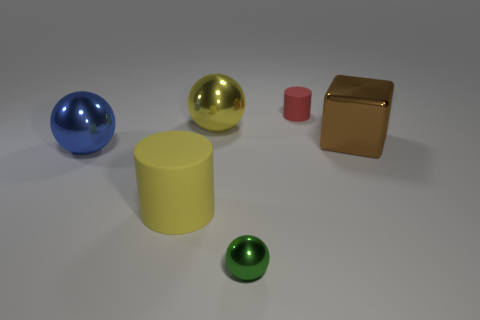There is another big object that is the same shape as the red matte thing; what color is it?
Offer a very short reply. Yellow. Are there any other things that have the same shape as the red object?
Your answer should be very brief. Yes. Do the small red rubber thing and the large object on the right side of the small green object have the same shape?
Ensure brevity in your answer.  No. What is the material of the yellow cylinder?
Ensure brevity in your answer.  Rubber. What size is the other matte object that is the same shape as the large matte thing?
Make the answer very short. Small. What number of other things are there of the same material as the blue sphere
Your answer should be compact. 3. Does the large brown block have the same material as the tiny sphere that is to the right of the big blue ball?
Ensure brevity in your answer.  Yes. Are there fewer red things behind the shiny block than red matte cylinders left of the small sphere?
Provide a short and direct response. No. There is a metallic thing that is left of the large yellow cylinder; what is its color?
Provide a succinct answer. Blue. What number of other objects are the same color as the big shiny cube?
Provide a short and direct response. 0. 